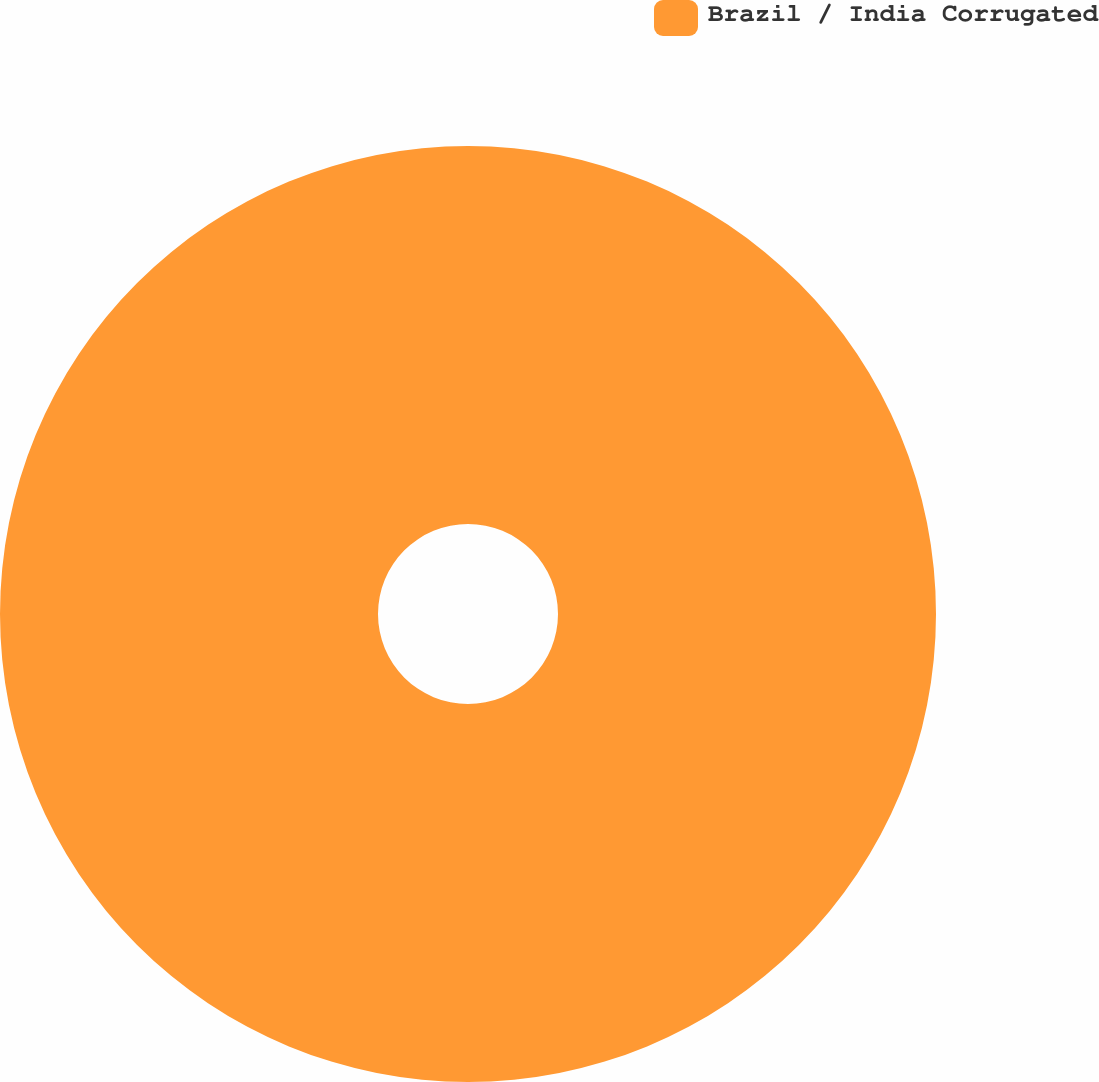Convert chart to OTSL. <chart><loc_0><loc_0><loc_500><loc_500><pie_chart><fcel>Brazil / India Corrugated<nl><fcel>100.0%<nl></chart> 